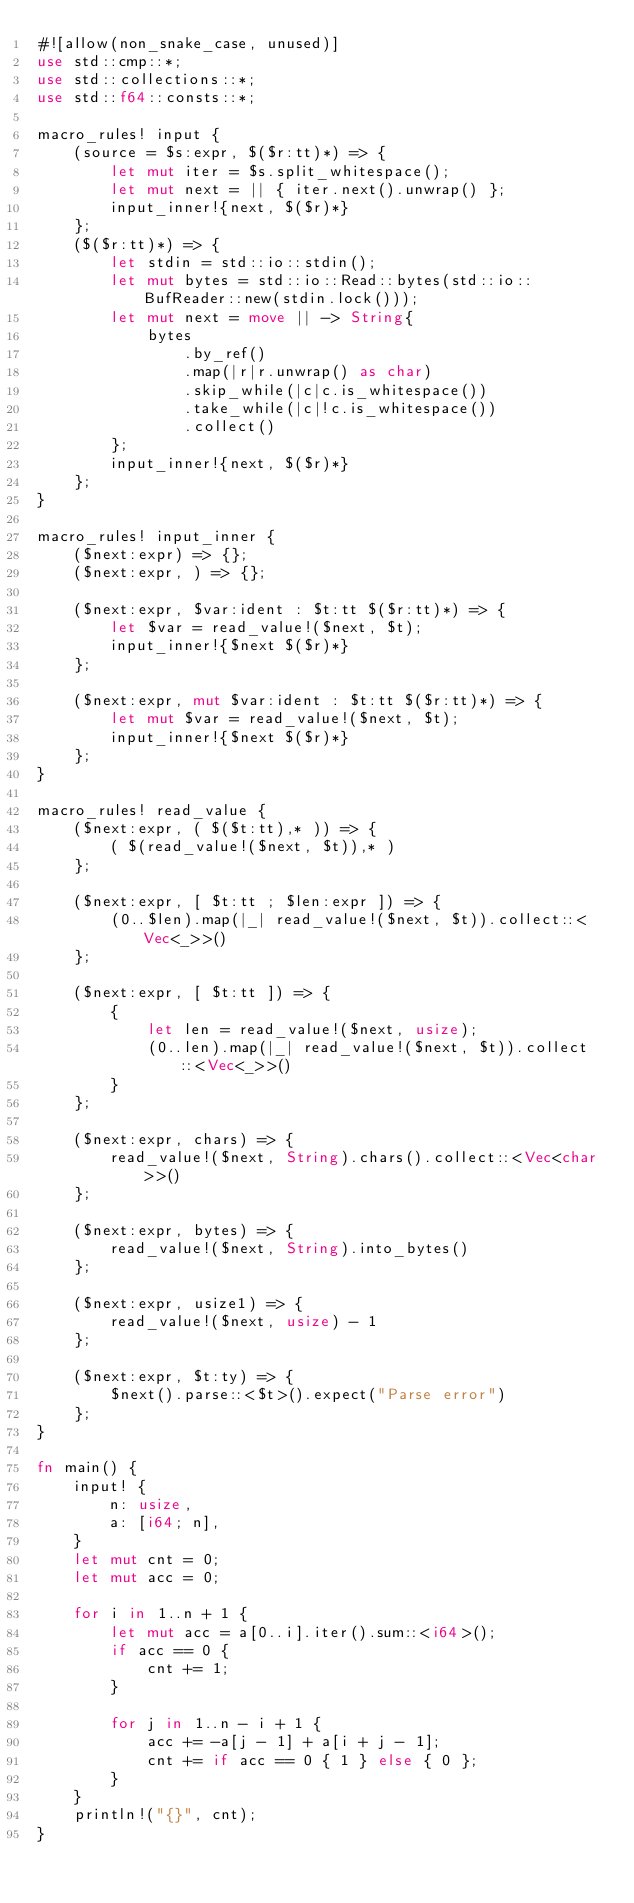Convert code to text. <code><loc_0><loc_0><loc_500><loc_500><_Rust_>#![allow(non_snake_case, unused)]
use std::cmp::*;
use std::collections::*;
use std::f64::consts::*;

macro_rules! input {
    (source = $s:expr, $($r:tt)*) => {
        let mut iter = $s.split_whitespace();
        let mut next = || { iter.next().unwrap() };
        input_inner!{next, $($r)*}
    };
    ($($r:tt)*) => {
        let stdin = std::io::stdin();
        let mut bytes = std::io::Read::bytes(std::io::BufReader::new(stdin.lock()));
        let mut next = move || -> String{
            bytes
                .by_ref()
                .map(|r|r.unwrap() as char)
                .skip_while(|c|c.is_whitespace())
                .take_while(|c|!c.is_whitespace())
                .collect()
        };
        input_inner!{next, $($r)*}
    };
}

macro_rules! input_inner {
    ($next:expr) => {};
    ($next:expr, ) => {};

    ($next:expr, $var:ident : $t:tt $($r:tt)*) => {
        let $var = read_value!($next, $t);
        input_inner!{$next $($r)*}
    };

    ($next:expr, mut $var:ident : $t:tt $($r:tt)*) => {
        let mut $var = read_value!($next, $t);
        input_inner!{$next $($r)*}
    };
}

macro_rules! read_value {
    ($next:expr, ( $($t:tt),* )) => {
        ( $(read_value!($next, $t)),* )
    };

    ($next:expr, [ $t:tt ; $len:expr ]) => {
        (0..$len).map(|_| read_value!($next, $t)).collect::<Vec<_>>()
    };

    ($next:expr, [ $t:tt ]) => {
        {
            let len = read_value!($next, usize);
            (0..len).map(|_| read_value!($next, $t)).collect::<Vec<_>>()
        }
    };

    ($next:expr, chars) => {
        read_value!($next, String).chars().collect::<Vec<char>>()
    };

    ($next:expr, bytes) => {
        read_value!($next, String).into_bytes()
    };

    ($next:expr, usize1) => {
        read_value!($next, usize) - 1
    };

    ($next:expr, $t:ty) => {
        $next().parse::<$t>().expect("Parse error")
    };
}

fn main() {
    input! {
        n: usize,
        a: [i64; n],
    }
    let mut cnt = 0;
    let mut acc = 0;

    for i in 1..n + 1 {
        let mut acc = a[0..i].iter().sum::<i64>();
        if acc == 0 {
            cnt += 1;
        }

        for j in 1..n - i + 1 {
            acc += -a[j - 1] + a[i + j - 1];
            cnt += if acc == 0 { 1 } else { 0 };
        }
    }
    println!("{}", cnt);
}
</code> 